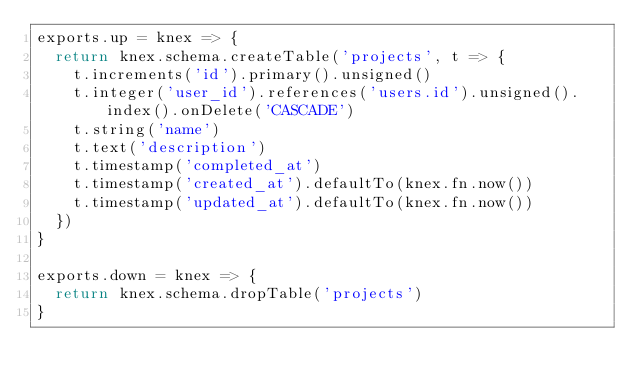<code> <loc_0><loc_0><loc_500><loc_500><_JavaScript_>exports.up = knex => {
  return knex.schema.createTable('projects', t => {
    t.increments('id').primary().unsigned()
    t.integer('user_id').references('users.id').unsigned().index().onDelete('CASCADE')
    t.string('name')
    t.text('description')
    t.timestamp('completed_at')
    t.timestamp('created_at').defaultTo(knex.fn.now())
    t.timestamp('updated_at').defaultTo(knex.fn.now())
  })
}

exports.down = knex => {
  return knex.schema.dropTable('projects')
}
</code> 